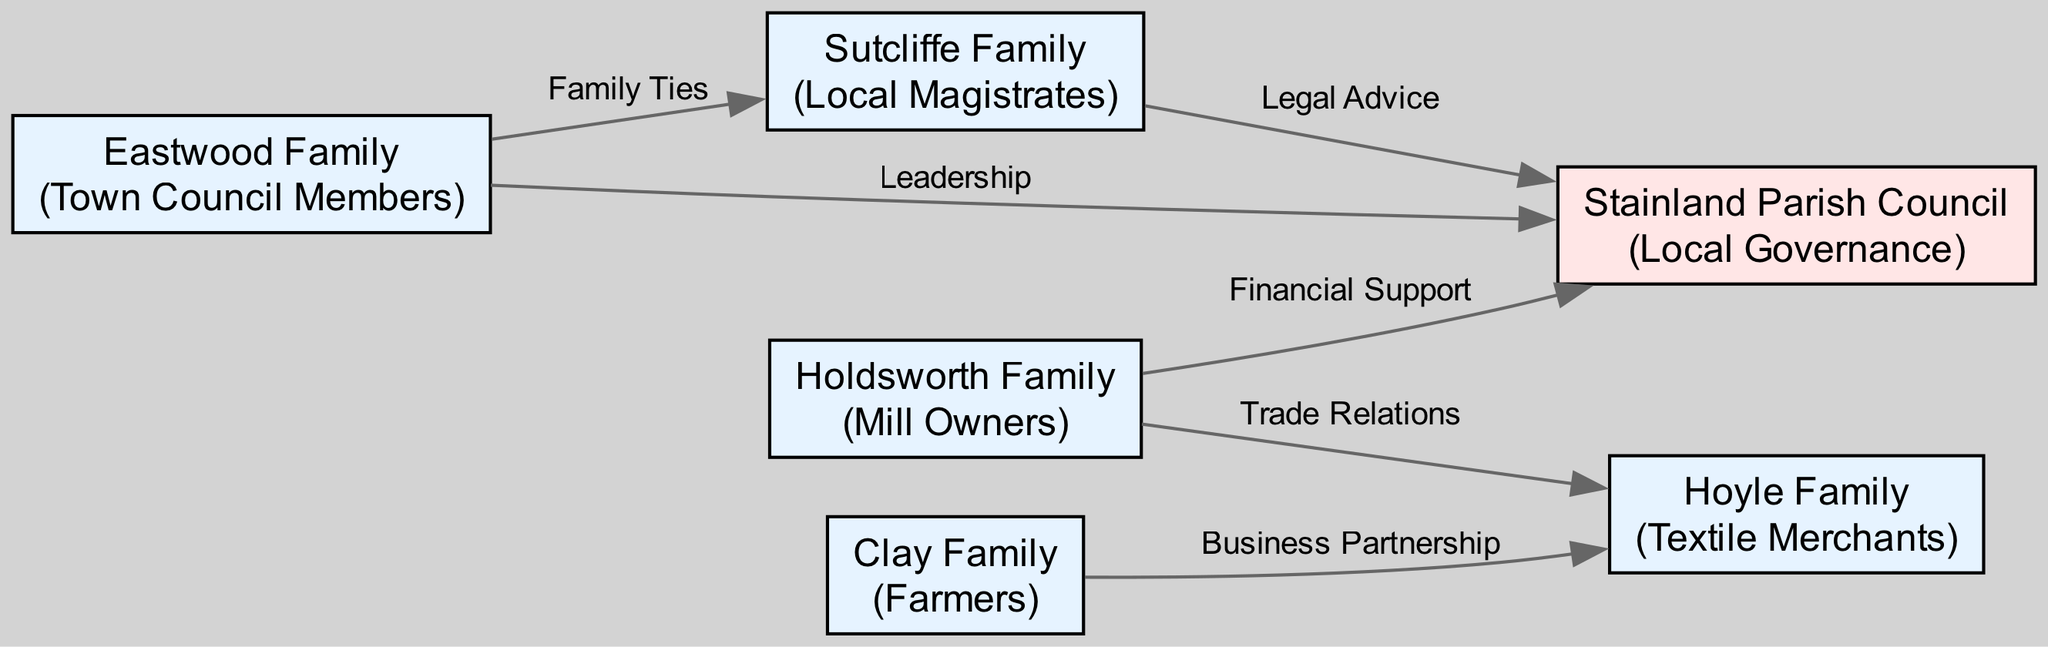What is the role of the Holdsworth Family? The Holdsworth Family is listed in the nodes of the diagram, and their role is identified as "Mill Owners".
Answer: Mill Owners How many families are connected to the Stainland Parish Council? By examining the edges, we see that three families (Holdsworth, Eastwood, and Sutcliffe) are connected to the Stainland Parish Council as they have direct relationships marked by edges.
Answer: Three What type of connection exists between the Eastwood Family and the Stainland Parish Council? The Eastwood Family is connected to the Stainland Parish Council through a "Leadership" edge, which describes the relationship.
Answer: Leadership Which family provides Legal Advice to the Stainland Parish Council? The diagram shows that the Sutcliffe Family has a connection labeled "Legal Advice" leading to the Stainland Parish Council.
Answer: Sutcliffe Family How are the Holdsworth Family and Hoyle Family connected? The diagram indicates that the Holdsworth Family and Hoyle Family are connected through "Trade Relations", denoting a business link between them.
Answer: Trade Relations Which families have a business relationship between them? The diagram indicates a business partnership between the Clay Family and the Hoyle Family as depicted in the edges with the label "Business Partnership".
Answer: Clay Family and Hoyle Family How many edges are shown in the diagram? By counting the connections made in the edges, there are six edges illustrated in the diagram that define the relationships between the nodes.
Answer: Six What is the primary social role of the families in the diagram? The diagram illustrates various roles for the families: Mill Owners, Town Council Members, Farmers, Local Magistrates, and Textile Merchants, which indicates they play significant roles in the local governance and economy.
Answer: Governance and Economy 